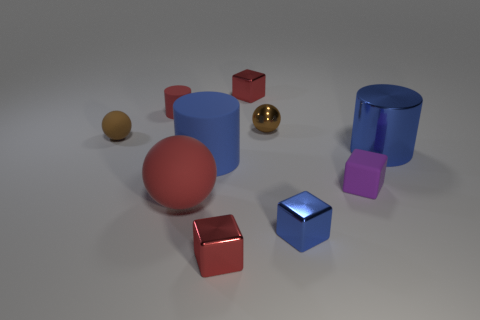There is a metal cylinder that is the same color as the big matte cylinder; what size is it?
Your response must be concise. Large. Are there any other large objects that have the same color as the big metal object?
Keep it short and to the point. Yes. What size is the ball that is made of the same material as the tiny blue object?
Make the answer very short. Small. Is the tiny red cylinder made of the same material as the tiny blue cube?
Provide a succinct answer. No. There is a big ball that is left of the blue metal object that is behind the small rubber thing that is to the right of the red rubber cylinder; what color is it?
Give a very brief answer. Red. What shape is the big red matte thing?
Ensure brevity in your answer.  Sphere. There is a large sphere; is it the same color as the cylinder on the left side of the big red sphere?
Your answer should be compact. Yes. Are there an equal number of small purple objects left of the big red thing and small cyan metallic cylinders?
Make the answer very short. Yes. How many red things have the same size as the blue matte thing?
Provide a short and direct response. 1. There is a big matte thing that is the same color as the big metal cylinder; what shape is it?
Give a very brief answer. Cylinder. 